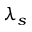<formula> <loc_0><loc_0><loc_500><loc_500>\lambda _ { s }</formula> 